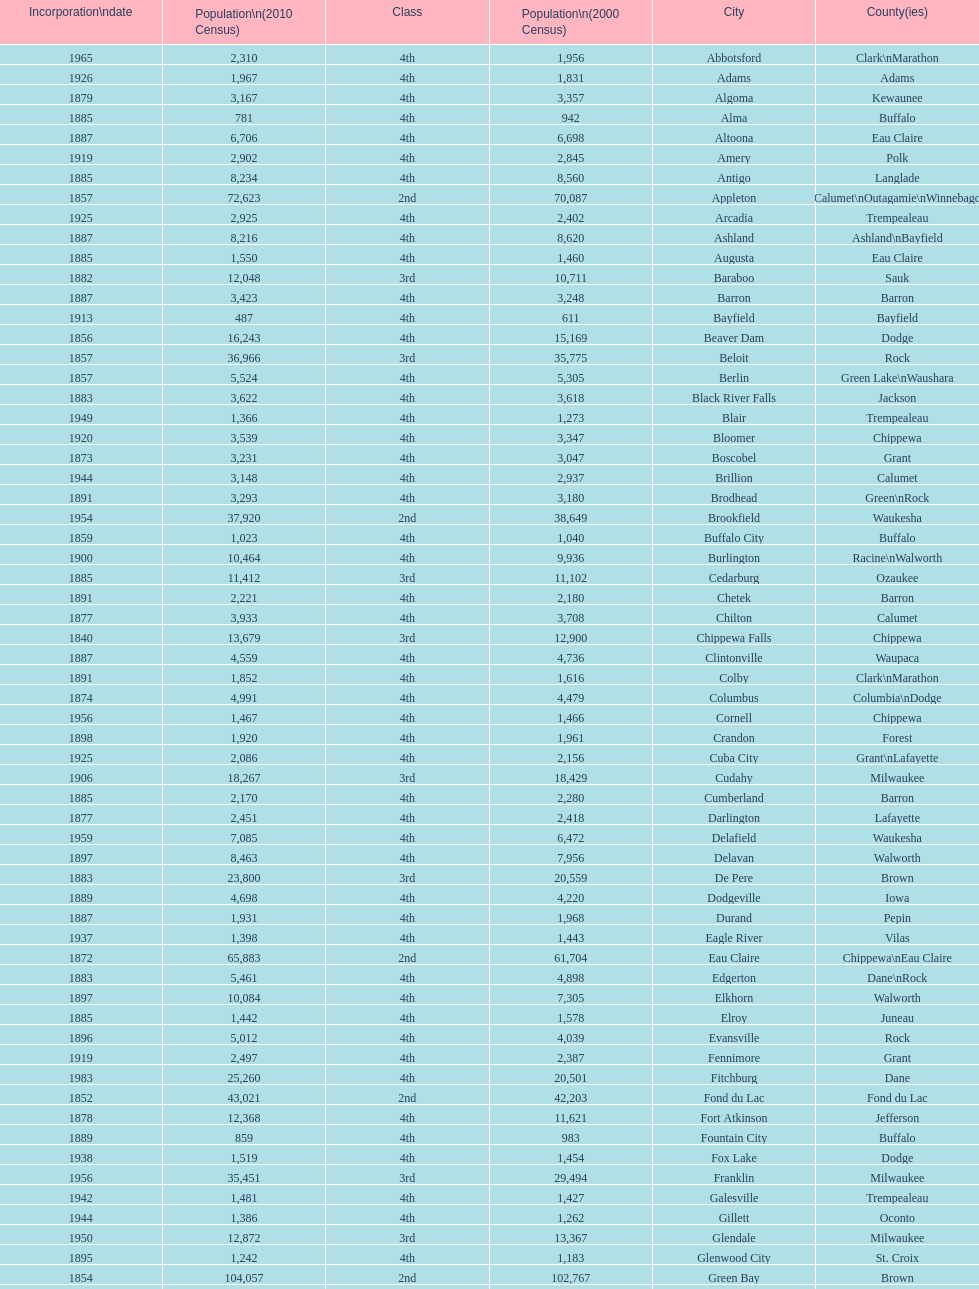How many cities have 1926 as their incorporation date? 2. Could you help me parse every detail presented in this table? {'header': ['Incorporation\\ndate', 'Population\\n(2010 Census)', 'Class', 'Population\\n(2000 Census)', 'City', 'County(ies)'], 'rows': [['1965', '2,310', '4th', '1,956', 'Abbotsford', 'Clark\\nMarathon'], ['1926', '1,967', '4th', '1,831', 'Adams', 'Adams'], ['1879', '3,167', '4th', '3,357', 'Algoma', 'Kewaunee'], ['1885', '781', '4th', '942', 'Alma', 'Buffalo'], ['1887', '6,706', '4th', '6,698', 'Altoona', 'Eau Claire'], ['1919', '2,902', '4th', '2,845', 'Amery', 'Polk'], ['1885', '8,234', '4th', '8,560', 'Antigo', 'Langlade'], ['1857', '72,623', '2nd', '70,087', 'Appleton', 'Calumet\\nOutagamie\\nWinnebago'], ['1925', '2,925', '4th', '2,402', 'Arcadia', 'Trempealeau'], ['1887', '8,216', '4th', '8,620', 'Ashland', 'Ashland\\nBayfield'], ['1885', '1,550', '4th', '1,460', 'Augusta', 'Eau Claire'], ['1882', '12,048', '3rd', '10,711', 'Baraboo', 'Sauk'], ['1887', '3,423', '4th', '3,248', 'Barron', 'Barron'], ['1913', '487', '4th', '611', 'Bayfield', 'Bayfield'], ['1856', '16,243', '4th', '15,169', 'Beaver Dam', 'Dodge'], ['1857', '36,966', '3rd', '35,775', 'Beloit', 'Rock'], ['1857', '5,524', '4th', '5,305', 'Berlin', 'Green Lake\\nWaushara'], ['1883', '3,622', '4th', '3,618', 'Black River Falls', 'Jackson'], ['1949', '1,366', '4th', '1,273', 'Blair', 'Trempealeau'], ['1920', '3,539', '4th', '3,347', 'Bloomer', 'Chippewa'], ['1873', '3,231', '4th', '3,047', 'Boscobel', 'Grant'], ['1944', '3,148', '4th', '2,937', 'Brillion', 'Calumet'], ['1891', '3,293', '4th', '3,180', 'Brodhead', 'Green\\nRock'], ['1954', '37,920', '2nd', '38,649', 'Brookfield', 'Waukesha'], ['1859', '1,023', '4th', '1,040', 'Buffalo City', 'Buffalo'], ['1900', '10,464', '4th', '9,936', 'Burlington', 'Racine\\nWalworth'], ['1885', '11,412', '3rd', '11,102', 'Cedarburg', 'Ozaukee'], ['1891', '2,221', '4th', '2,180', 'Chetek', 'Barron'], ['1877', '3,933', '4th', '3,708', 'Chilton', 'Calumet'], ['1840', '13,679', '3rd', '12,900', 'Chippewa Falls', 'Chippewa'], ['1887', '4,559', '4th', '4,736', 'Clintonville', 'Waupaca'], ['1891', '1,852', '4th', '1,616', 'Colby', 'Clark\\nMarathon'], ['1874', '4,991', '4th', '4,479', 'Columbus', 'Columbia\\nDodge'], ['1956', '1,467', '4th', '1,466', 'Cornell', 'Chippewa'], ['1898', '1,920', '4th', '1,961', 'Crandon', 'Forest'], ['1925', '2,086', '4th', '2,156', 'Cuba City', 'Grant\\nLafayette'], ['1906', '18,267', '3rd', '18,429', 'Cudahy', 'Milwaukee'], ['1885', '2,170', '4th', '2,280', 'Cumberland', 'Barron'], ['1877', '2,451', '4th', '2,418', 'Darlington', 'Lafayette'], ['1959', '7,085', '4th', '6,472', 'Delafield', 'Waukesha'], ['1897', '8,463', '4th', '7,956', 'Delavan', 'Walworth'], ['1883', '23,800', '3rd', '20,559', 'De Pere', 'Brown'], ['1889', '4,698', '4th', '4,220', 'Dodgeville', 'Iowa'], ['1887', '1,931', '4th', '1,968', 'Durand', 'Pepin'], ['1937', '1,398', '4th', '1,443', 'Eagle River', 'Vilas'], ['1872', '65,883', '2nd', '61,704', 'Eau Claire', 'Chippewa\\nEau Claire'], ['1883', '5,461', '4th', '4,898', 'Edgerton', 'Dane\\nRock'], ['1897', '10,084', '4th', '7,305', 'Elkhorn', 'Walworth'], ['1885', '1,442', '4th', '1,578', 'Elroy', 'Juneau'], ['1896', '5,012', '4th', '4,039', 'Evansville', 'Rock'], ['1919', '2,497', '4th', '2,387', 'Fennimore', 'Grant'], ['1983', '25,260', '4th', '20,501', 'Fitchburg', 'Dane'], ['1852', '43,021', '2nd', '42,203', 'Fond du Lac', 'Fond du Lac'], ['1878', '12,368', '4th', '11,621', 'Fort Atkinson', 'Jefferson'], ['1889', '859', '4th', '983', 'Fountain City', 'Buffalo'], ['1938', '1,519', '4th', '1,454', 'Fox Lake', 'Dodge'], ['1956', '35,451', '3rd', '29,494', 'Franklin', 'Milwaukee'], ['1942', '1,481', '4th', '1,427', 'Galesville', 'Trempealeau'], ['1944', '1,386', '4th', '1,262', 'Gillett', 'Oconto'], ['1950', '12,872', '3rd', '13,367', 'Glendale', 'Milwaukee'], ['1895', '1,242', '4th', '1,183', 'Glenwood City', 'St. Croix'], ['1854', '104,057', '2nd', '102,767', 'Green Bay', 'Brown'], ['1957', '36,720', '3rd', '35,476', 'Greenfield', 'Milwaukee'], ['1962', '960', '4th', '1,100', 'Green Lake', 'Green Lake'], ['1891', '1,026', '4th', '1,079', 'Greenwood', 'Clark'], ['1883', '14,223', '3rd', '10,905', 'Hartford', 'Dodge\\nWashington'], ['1915', '2,318', '4th', '2,129', 'Hayward', 'Sawyer'], ['1885', '1,417', '4th', '1,302', 'Hillsboro', 'Vernon'], ['1897', '3,655', '4th', '3,775', 'Horicon', 'Dodge'], ['1858', '12,719', '4th', '8,775', 'Hudson', 'St. Croix'], ['1918', '1,547', '4th', '1,818', 'Hurley', 'Iron'], ['1942', '1,336', '4th', '1,244', 'Independence', 'Trempealeau'], ['1853', '63,575', '2nd', '59,498', 'Janesville', 'Rock'], ['1878', '7,973', '4th', '7,338', 'Jefferson', 'Jefferson'], ['1887', '2,814', '4th', '2,485', 'Juneau', 'Dodge'], ['1885', '15,462', '3rd', '12,983', 'Kaukauna', 'Outagamie'], ['1850', '99,218', '2nd', '90,352', 'Kenosha', 'Kenosha'], ['1883', '2,952', '4th', '2,806', 'Kewaunee', 'Kewaunee'], ['1920', '3,738', '4th', '3,450', 'Kiel', 'Calumet\\nManitowoc'], ['1856', '51,320', '2nd', '51,818', 'La Crosse', 'La Crosse'], ['1905', '3,414', '4th', '3,932', 'Ladysmith', 'Rusk'], ['1883', '7,651', '4th', '7,148', 'Lake Geneva', 'Walworth'], ['1905', '5,708', '4th', '4,843', 'Lake Mills', 'Jefferson'], ['1878', '3,868', '4th', '4,070', 'Lancaster', 'Grant'], ['1941', '3,050', '4th', '2,882', 'Lodi', 'Columbia'], ['1948', '1,261', '4th', '1,308', 'Loyal', 'Clark'], ['1856', '233,209', '2nd', '208,054', 'Madison', 'Dane'], ['1954', '1,371', '4th', '1,330', 'Manawa', 'Waupaca'], ['1870', '33,736', '3rd', '34,053', 'Manitowoc', 'Manitowoc'], ['1887', '10,968', '3rd', '11,749', 'Marinette', 'Marinette'], ['1898', '1,260', '4th', '1,297', 'Marion', 'Shawano\\nWaupaca'], ['1959', '1,476', '4th', '1,396', 'Markesan', 'Green Lake'], ['1883', '19,118', '3rd', '18,800', 'Marshfield', 'Marathon\\nWood'], ['1883', '4,423', '4th', '3,740', 'Mauston', 'Juneau'], ['1885', '5,154', '4th', '4,902', 'Mayville', 'Dodge'], ['1889', '4,326', '4th', '4,350', 'Medford', 'Taylor'], ['1907', '731', '4th', '845', 'Mellen', 'Ashland'], ['1874', '17,353', '3rd', '16,331', 'Menasha', 'Calumet\\nWinnebago'], ['1882', '16,264', '4th', '14,937', 'Menomonie', 'Dunn'], ['1957', '23,132', '4th', '22,643', 'Mequon', 'Ozaukee'], ['1883', '9,661', '4th', '10,146', 'Merrill', 'Lincoln'], ['1963', '17,442', '3rd', '15,770', 'Middleton', 'Dane'], ['1969', '5,546', '4th', '5,132', 'Milton', 'Rock'], ['1846', '594,833', '1st', '596,974', 'Milwaukee', 'Milwaukee\\nWashington\\nWaukesha'], ['1857', '2,487', '4th', '2,617', 'Mineral Point', 'Iowa'], ['1889', '2,777', '4th', '2,634', 'Mondovi', 'Buffalo'], ['1969', '7,533', '4th', '8,018', 'Monona', 'Dane'], ['1882', '10,827', '4th', '10,843', 'Monroe', 'Green'], ['1938', '1,495', '4th', '1,397', 'Montello', 'Marquette'], ['1924', '807', '4th', '838', 'Montreal', 'Iron'], ['1931', '3,988', '4th', '4,063', 'Mosinee', 'Marathon'], ['1964', '24,135', '3rd', '21,397', 'Muskego', 'Waukesha'], ['1873', '25,501', '3rd', '24,507', 'Neenah', 'Winnebago'], ['1882', '2,463', '4th', '2,731', 'Neillsville', 'Clark'], ['1926', '2,580', '4th', '2,590', 'Nekoosa', 'Wood'], ['1959', '39,584', '3rd', '38,220', 'New Berlin', 'Waukesha'], ['1889', '3,236', '4th', '3,301', 'New Holstein', 'Calumet'], ['1889', '2,554', '4th', '1,436', 'New Lisbon', 'Juneau'], ['1877', '7,295', '4th', '7,085', 'New London', 'Outagamie\\nWaupaca'], ['1885', '8,375', '4th', '6,310', 'New Richmond', 'St. Croix'], ['1992', '1,624', '4th', '1,880', 'Niagara', 'Marinette'], ['1955', '34,451', '3rd', '28,456', 'Oak Creek', 'Milwaukee'], ['1875', '15,712', '3rd', '12,382', 'Oconomowoc', 'Waukesha'], ['1869', '4,513', '4th', '4,708', 'Oconto', 'Oconto'], ['1919', '2,891', '4th', '2,843', 'Oconto Falls', 'Oconto'], ['1944', '3,517', '4th', '3,177', 'Omro', 'Winnebago'], ['1887', '17,736', '4th', '14,839', 'Onalaska', 'La Crosse'], ['1853', '66,083', '2nd', '62,916', 'Oshkosh', 'Winnebago'], ['1941', '1,701', '4th', '1,669', 'Osseo', 'Trempealeau'], ['1925', '940', '4th', '936', 'Owen', 'Clark'], ['1912', '2,462', '4th', '2,739', 'Park Falls', 'Price'], ['1903', '3,502', '4th', '3,474', 'Peshtigo', 'Marinette'], ['1999', '13,195', '3rd', '11,783', 'Pewaukee', 'Waukesha'], ['1891', '1,478', '4th', '1,675', 'Phillips', 'Price'], ['1887', '874', '4th', '866', 'Pittsville', 'Wood'], ['1876', '11,224', '4th', '9,989', 'Platteville', 'Grant'], ['1877', '8,445', '4th', '7,781', 'Plymouth', 'Sheboygan'], ['1882', '11,250', '4th', '10,467', 'Port Washington', 'Ozaukee'], ['1854', '10,324', '4th', '9,728', 'Portage', 'Columbia'], ['1872', '5,911', '4th', '6,018', 'Prairie du Chien', 'Crawford'], ['1857', '4,258', '4th', '3,764', 'Prescott', 'Pierce'], ['1920', '1,214', '4th', '1,504', 'Princeton', 'Green Lake'], ['1848', '78,860', '2nd', '81,855', 'Racine', 'Racine'], ['1887', '10,014', '4th', '7,827', 'Reedsburg', 'Sauk'], ['1894', '7,798', '4th', '7,735', 'Rhinelander', 'Oneida'], ['1887', '8,438', '4th', '8,312', 'Rice Lake', 'Barron'], ['1887', '5,184', '4th', '5,114', 'Richland Center', 'Richland'], ['1858', '7,733', '4th', '7,450', 'Ripon', 'Fond du Lac'], ['1875', '15,000', '3rd', '12,560', 'River Falls', 'Pierce\\nSt. Croix'], ['1958', '2,133', '4th', '2,033', 'St. Croix Falls', 'Polk'], ['1951', '9,365', '4th', '8,662', 'St. Francis', 'Milwaukee'], ['1951', '2,169', '4th', '2,117', 'Schofield', 'Marathon'], ['1879', '3,451', '4th', '3,335', 'Seymour', 'Outagamie'], ['1874', '9,305', '4th', '8,298', 'Shawano', 'Shawano'], ['1853', '49,288', '2nd', '50,792', 'Sheboygan', 'Sheboygan'], ['1913', '7,775', '4th', '6,772', 'Sheboygan Falls', 'Sheboygan'], ['1961', '1,347', '4th', '1,309', 'Shell Lake', 'Washburn'], ['1889', '1,226', '4th', '1,246', 'Shullsburg', 'Lafayette'], ['1897', '21,156', '4th', '21,256', 'South Milwaukee', 'Milwaukee'], ['1883', '9,522', '4th', '8,648', 'Sparta', 'Monroe'], ['1909', '2,682', '4th', '2,653', 'Spooner', 'Washburn'], ['1898', '3,608', '4th', '1,898', 'Stanley', 'Chippewa\\nClark'], ['1858', '26,717', '3rd', '24,551', 'Stevens Point', 'Portage'], ['1882', '12,611', '4th', '12,354', 'Stoughton', 'Dane'], ['1883', '9,144', '4th', '9,437', 'Sturgeon Bay', 'Door'], ['1958', '29,364', '3rd', '20,369', 'Sun Prairie', 'Dane'], ['1858', '27,244', '2nd', '27,368', 'Superior', 'Douglas'], ['1948', '1,621', '4th', '1,536', 'Thorp', 'Clark'], ['1883', '9,093', '4th', '8,419', 'Tomah', 'Monroe'], ['1891', '3,397', '4th', '3,770', 'Tomahawk', 'Lincoln'], ['1878', '11,712', '3rd', '12,639', 'Two Rivers', 'Manitowoc'], ['1977', '10,619', '4th', '7,052', 'Verona', 'Dane'], ['1885', '5,079', '4th', '4,335', 'Viroqua', 'Vernon'], ['1904', '2,117', '4th', '2,280', 'Washburn', 'Bayfield'], ['1962', '3,333', '4th', '3,259', 'Waterloo', 'Jefferson'], ['1853', '23,861', '3rd', '21,598', 'Watertown', 'Dodge\\nJefferson'], ['1895', '70,718', '2nd', '64,825', 'Waukesha', 'Waukesha'], ['1878', '6,069', '4th', '5,676', 'Waupaca', 'Waupaca'], ['1878', '11,340', '4th', '10,944', 'Waupun', 'Dodge\\nFond du Lac'], ['1872', '39,106', '3rd', '38,426', 'Wausau', 'Marathon'], ['1901', '2,218', '4th', '1,998', 'Wautoma', 'Waushara'], ['1897', '46,396', '2nd', '47,271', 'Wauwatosa', 'Milwaukee'], ['1906', '60,411', '2nd', '61,254', 'West Allis', 'Milwaukee'], ['1885', '31,078', '3rd', '28,152', 'West Bend', 'Washington'], ['1920', '2,200', '4th', '2,045', 'Westby', 'Vernon'], ['1939', '1,900', '4th', '1,806', 'Weyauwega', 'Waupaca'], ['1941', '1,558', '4th', '1,651', 'Whitehall', 'Trempealeau'], ['1885', '14,390', '4th', '13,437', 'Whitewater', 'Jefferson\\nWalworth'], ['1925', '2,678', '4th', '2,418', 'Wisconsin Dells', 'Adams\\nColumbia\\nJuneau\\nSauk'], ['1869', '18,367', '3rd', '18,435', 'Wisconsin Rapids', 'Wood']]} 